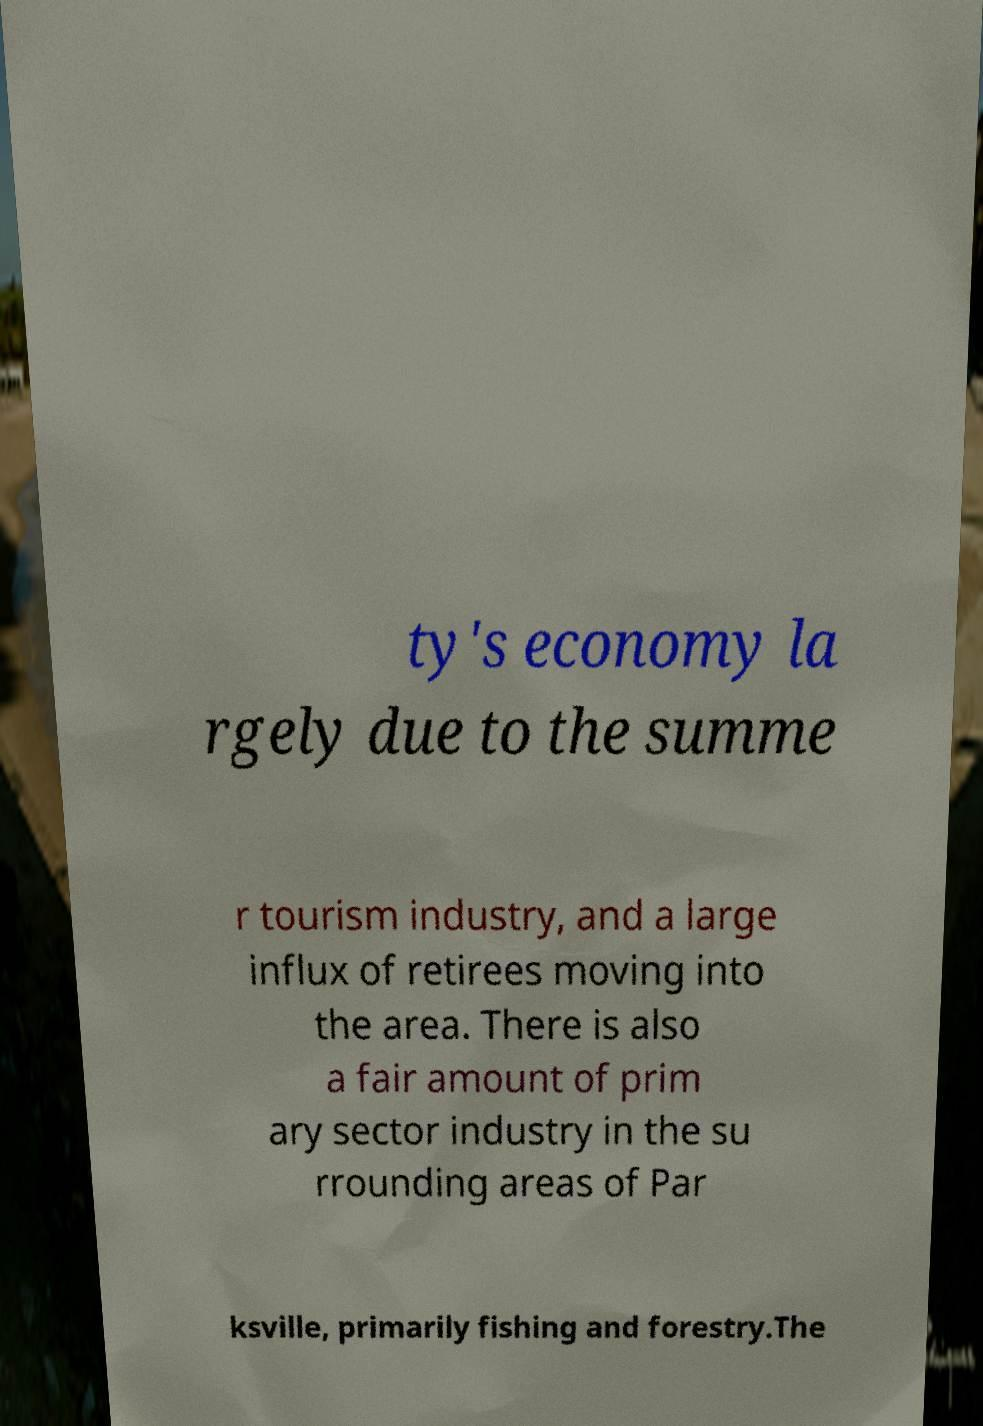Please identify and transcribe the text found in this image. ty's economy la rgely due to the summe r tourism industry, and a large influx of retirees moving into the area. There is also a fair amount of prim ary sector industry in the su rrounding areas of Par ksville, primarily fishing and forestry.The 